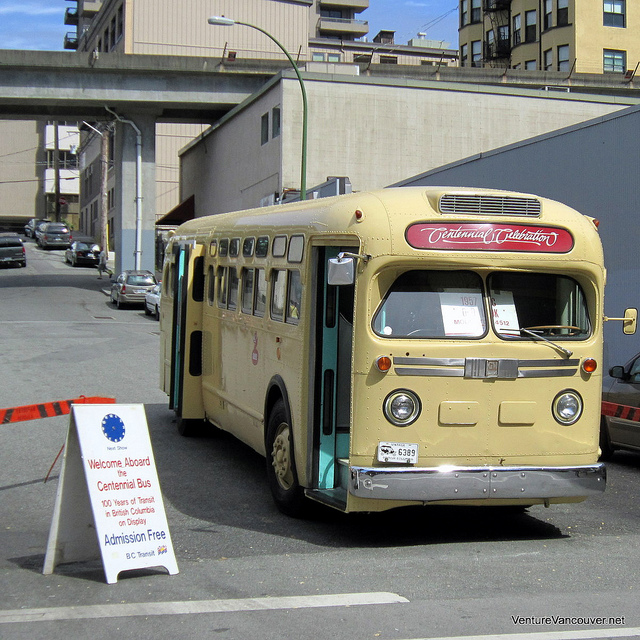Please transcribe the text information in this image. Welcome Aboard the Bus Centennial VentureVancouver.net 100 of Free Admission 6389 